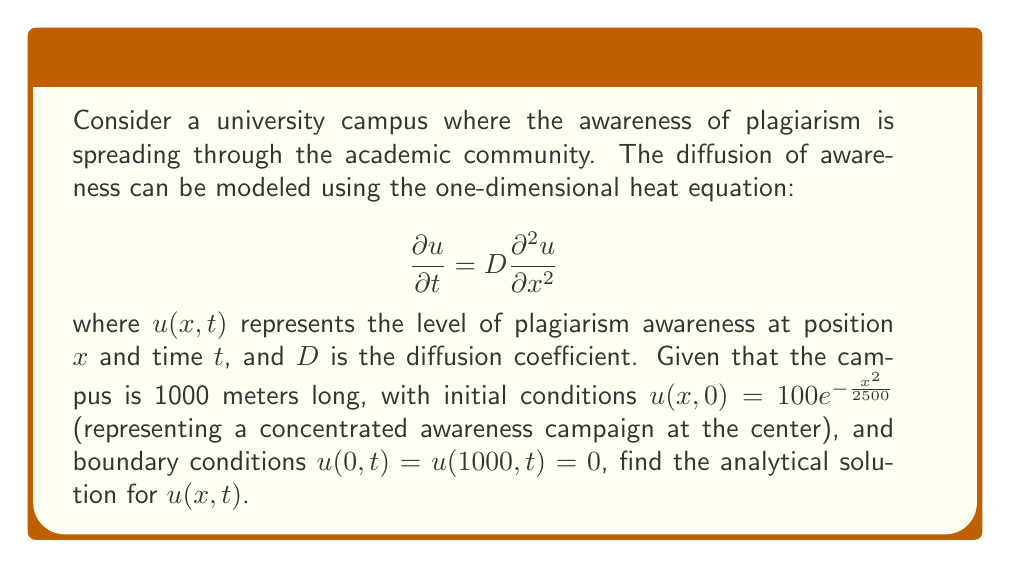Provide a solution to this math problem. To solve this problem, we'll use the method of separation of variables:

1) Assume the solution has the form: $u(x,t) = X(x)T(t)$

2) Substitute this into the heat equation:
   $$X(x)T'(t) = DX''(x)T(t)$$

3) Separate variables:
   $$\frac{T'(t)}{T(t)} = D\frac{X''(x)}{X(x)} = -\lambda$$

4) This gives us two ODEs:
   $$T'(t) + \lambda DT(t) = 0$$
   $$X''(x) + \lambda X(x) = 0$$

5) The boundary conditions $u(0,t) = u(1000,t) = 0$ imply $X(0) = X(1000) = 0$. This gives the eigenvalues:
   $$\lambda_n = \left(\frac{n\pi}{1000}\right)^2, n = 1,2,3,...$$

6) The corresponding eigenfunctions are:
   $$X_n(x) = \sin\left(\frac{n\pi x}{1000}\right)$$

7) The general solution is:
   $$u(x,t) = \sum_{n=1}^{\infty} A_n \sin\left(\frac{n\pi x}{1000}\right)e^{-D\left(\frac{n\pi}{1000}\right)^2t}$$

8) To find $A_n$, we use the initial condition:
   $$100e^{-\frac{x^2}{2500}} = \sum_{n=1}^{\infty} A_n \sin\left(\frac{n\pi x}{1000}\right)$$

9) Multiply both sides by $\sin\left(\frac{m\pi x}{1000}\right)$ and integrate from 0 to 1000:
   $$A_n = \frac{2}{1000}\int_0^{1000} 100e^{-\frac{x^2}{2500}}\sin\left(\frac{n\pi x}{1000}\right)dx$$

10) This integral can be evaluated (though it's complicated), giving:
    $$A_n = 100\sqrt{\frac{2\pi}{5}}e^{-\frac{n^2\pi^2}{8000}}\sin\left(\frac{n\pi}{2}\right)$$

Therefore, the final solution is:

$$u(x,t) = 100\sqrt{\frac{2\pi}{5}}\sum_{n=1}^{\infty} e^{-\frac{n^2\pi^2}{8000}}\sin\left(\frac{n\pi}{2}\right)\sin\left(\frac{n\pi x}{1000}\right)e^{-D\left(\frac{n\pi}{1000}\right)^2t}$$
Answer: $$u(x,t) = 100\sqrt{\frac{2\pi}{5}}\sum_{n=1}^{\infty} e^{-\frac{n^2\pi^2}{8000}}\sin\left(\frac{n\pi}{2}\right)\sin\left(\frac{n\pi x}{1000}\right)e^{-D\left(\frac{n\pi}{1000}\right)^2t}$$ 